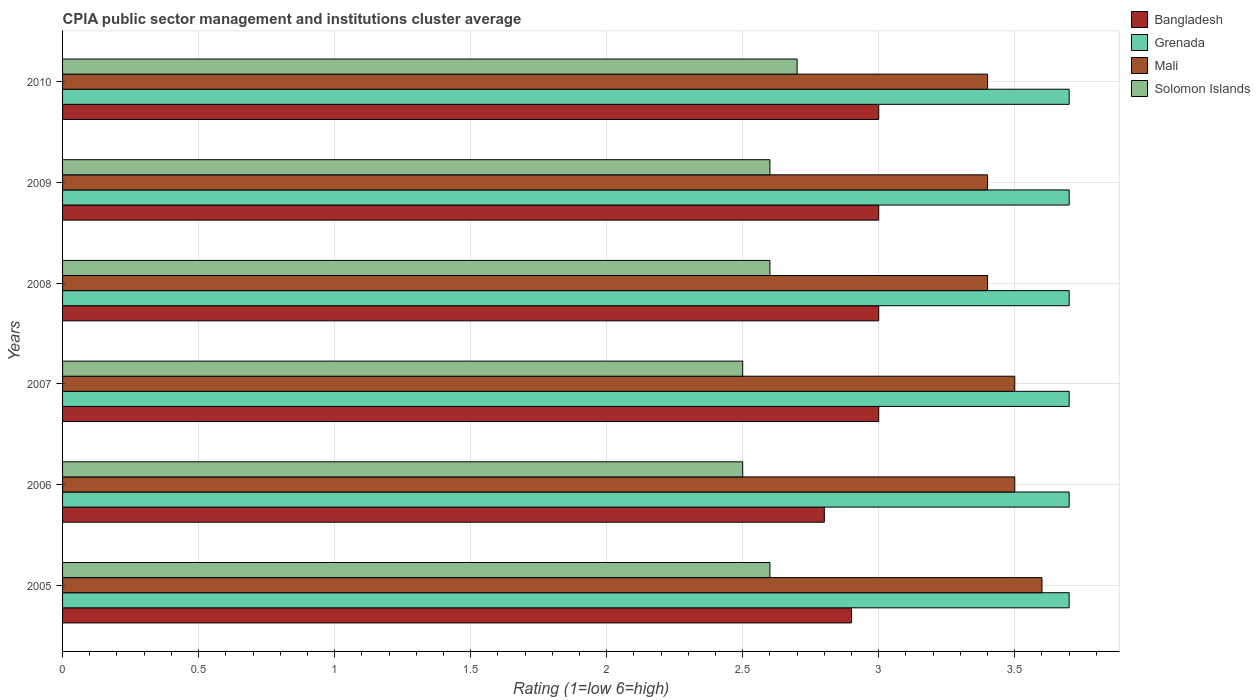How many groups of bars are there?
Your answer should be very brief. 6. Are the number of bars per tick equal to the number of legend labels?
Ensure brevity in your answer.  Yes. Are the number of bars on each tick of the Y-axis equal?
Provide a short and direct response. Yes. How many bars are there on the 4th tick from the bottom?
Offer a very short reply. 4. What is the label of the 3rd group of bars from the top?
Your answer should be compact. 2008. Across all years, what is the minimum CPIA rating in Bangladesh?
Your answer should be very brief. 2.8. In which year was the CPIA rating in Solomon Islands maximum?
Your answer should be compact. 2010. What is the total CPIA rating in Solomon Islands in the graph?
Ensure brevity in your answer.  15.5. What is the difference between the CPIA rating in Mali in 2007 and that in 2008?
Make the answer very short. 0.1. What is the average CPIA rating in Solomon Islands per year?
Your response must be concise. 2.58. In the year 2005, what is the difference between the CPIA rating in Mali and CPIA rating in Bangladesh?
Give a very brief answer. 0.7. What is the ratio of the CPIA rating in Bangladesh in 2007 to that in 2010?
Your answer should be compact. 1. What is the difference between the highest and the lowest CPIA rating in Solomon Islands?
Your response must be concise. 0.2. In how many years, is the CPIA rating in Mali greater than the average CPIA rating in Mali taken over all years?
Your response must be concise. 3. Is the sum of the CPIA rating in Grenada in 2008 and 2010 greater than the maximum CPIA rating in Solomon Islands across all years?
Offer a terse response. Yes. Is it the case that in every year, the sum of the CPIA rating in Grenada and CPIA rating in Bangladesh is greater than the sum of CPIA rating in Mali and CPIA rating in Solomon Islands?
Make the answer very short. Yes. What does the 3rd bar from the top in 2006 represents?
Your response must be concise. Grenada. What does the 2nd bar from the bottom in 2007 represents?
Make the answer very short. Grenada. How many bars are there?
Give a very brief answer. 24. Are all the bars in the graph horizontal?
Provide a short and direct response. Yes. What is the difference between two consecutive major ticks on the X-axis?
Offer a terse response. 0.5. Where does the legend appear in the graph?
Your answer should be compact. Top right. What is the title of the graph?
Give a very brief answer. CPIA public sector management and institutions cluster average. Does "United States" appear as one of the legend labels in the graph?
Provide a short and direct response. No. What is the label or title of the X-axis?
Make the answer very short. Rating (1=low 6=high). What is the label or title of the Y-axis?
Ensure brevity in your answer.  Years. What is the Rating (1=low 6=high) in Bangladesh in 2005?
Give a very brief answer. 2.9. What is the Rating (1=low 6=high) in Bangladesh in 2006?
Your answer should be very brief. 2.8. What is the Rating (1=low 6=high) in Grenada in 2006?
Offer a very short reply. 3.7. What is the Rating (1=low 6=high) of Grenada in 2007?
Your answer should be compact. 3.7. What is the Rating (1=low 6=high) in Bangladesh in 2008?
Keep it short and to the point. 3. What is the Rating (1=low 6=high) in Grenada in 2008?
Make the answer very short. 3.7. What is the Rating (1=low 6=high) of Mali in 2008?
Keep it short and to the point. 3.4. What is the Rating (1=low 6=high) of Solomon Islands in 2010?
Keep it short and to the point. 2.7. Across all years, what is the maximum Rating (1=low 6=high) in Bangladesh?
Your answer should be very brief. 3. Across all years, what is the maximum Rating (1=low 6=high) in Grenada?
Provide a succinct answer. 3.7. Across all years, what is the maximum Rating (1=low 6=high) of Mali?
Keep it short and to the point. 3.6. Across all years, what is the minimum Rating (1=low 6=high) in Bangladesh?
Ensure brevity in your answer.  2.8. Across all years, what is the minimum Rating (1=low 6=high) in Solomon Islands?
Keep it short and to the point. 2.5. What is the total Rating (1=low 6=high) in Mali in the graph?
Ensure brevity in your answer.  20.8. What is the total Rating (1=low 6=high) in Solomon Islands in the graph?
Provide a succinct answer. 15.5. What is the difference between the Rating (1=low 6=high) of Bangladesh in 2005 and that in 2006?
Your response must be concise. 0.1. What is the difference between the Rating (1=low 6=high) in Mali in 2005 and that in 2006?
Make the answer very short. 0.1. What is the difference between the Rating (1=low 6=high) of Grenada in 2005 and that in 2007?
Give a very brief answer. 0. What is the difference between the Rating (1=low 6=high) of Solomon Islands in 2005 and that in 2007?
Provide a short and direct response. 0.1. What is the difference between the Rating (1=low 6=high) in Grenada in 2005 and that in 2008?
Ensure brevity in your answer.  0. What is the difference between the Rating (1=low 6=high) of Solomon Islands in 2005 and that in 2008?
Offer a very short reply. 0. What is the difference between the Rating (1=low 6=high) of Mali in 2005 and that in 2009?
Your answer should be very brief. 0.2. What is the difference between the Rating (1=low 6=high) in Solomon Islands in 2005 and that in 2009?
Provide a succinct answer. 0. What is the difference between the Rating (1=low 6=high) in Bangladesh in 2005 and that in 2010?
Your answer should be very brief. -0.1. What is the difference between the Rating (1=low 6=high) in Solomon Islands in 2005 and that in 2010?
Provide a short and direct response. -0.1. What is the difference between the Rating (1=low 6=high) in Solomon Islands in 2006 and that in 2007?
Give a very brief answer. 0. What is the difference between the Rating (1=low 6=high) of Bangladesh in 2006 and that in 2008?
Your response must be concise. -0.2. What is the difference between the Rating (1=low 6=high) in Grenada in 2006 and that in 2008?
Keep it short and to the point. 0. What is the difference between the Rating (1=low 6=high) of Mali in 2006 and that in 2008?
Ensure brevity in your answer.  0.1. What is the difference between the Rating (1=low 6=high) in Grenada in 2006 and that in 2009?
Provide a short and direct response. 0. What is the difference between the Rating (1=low 6=high) in Solomon Islands in 2006 and that in 2009?
Your answer should be compact. -0.1. What is the difference between the Rating (1=low 6=high) of Solomon Islands in 2006 and that in 2010?
Offer a terse response. -0.2. What is the difference between the Rating (1=low 6=high) of Grenada in 2007 and that in 2008?
Give a very brief answer. 0. What is the difference between the Rating (1=low 6=high) of Solomon Islands in 2007 and that in 2008?
Offer a terse response. -0.1. What is the difference between the Rating (1=low 6=high) in Bangladesh in 2007 and that in 2009?
Offer a terse response. 0. What is the difference between the Rating (1=low 6=high) of Grenada in 2007 and that in 2009?
Keep it short and to the point. 0. What is the difference between the Rating (1=low 6=high) of Mali in 2007 and that in 2009?
Your answer should be very brief. 0.1. What is the difference between the Rating (1=low 6=high) of Bangladesh in 2007 and that in 2010?
Your answer should be compact. 0. What is the difference between the Rating (1=low 6=high) of Grenada in 2007 and that in 2010?
Offer a very short reply. 0. What is the difference between the Rating (1=low 6=high) of Bangladesh in 2008 and that in 2009?
Give a very brief answer. 0. What is the difference between the Rating (1=low 6=high) in Solomon Islands in 2008 and that in 2009?
Make the answer very short. 0. What is the difference between the Rating (1=low 6=high) of Solomon Islands in 2008 and that in 2010?
Offer a terse response. -0.1. What is the difference between the Rating (1=low 6=high) of Bangladesh in 2009 and that in 2010?
Your response must be concise. 0. What is the difference between the Rating (1=low 6=high) of Mali in 2009 and that in 2010?
Provide a succinct answer. 0. What is the difference between the Rating (1=low 6=high) of Bangladesh in 2005 and the Rating (1=low 6=high) of Mali in 2006?
Your response must be concise. -0.6. What is the difference between the Rating (1=low 6=high) of Bangladesh in 2005 and the Rating (1=low 6=high) of Solomon Islands in 2006?
Offer a very short reply. 0.4. What is the difference between the Rating (1=low 6=high) of Grenada in 2005 and the Rating (1=low 6=high) of Mali in 2006?
Offer a terse response. 0.2. What is the difference between the Rating (1=low 6=high) of Bangladesh in 2005 and the Rating (1=low 6=high) of Mali in 2007?
Offer a terse response. -0.6. What is the difference between the Rating (1=low 6=high) in Grenada in 2005 and the Rating (1=low 6=high) in Mali in 2007?
Offer a very short reply. 0.2. What is the difference between the Rating (1=low 6=high) in Grenada in 2005 and the Rating (1=low 6=high) in Solomon Islands in 2007?
Keep it short and to the point. 1.2. What is the difference between the Rating (1=low 6=high) in Mali in 2005 and the Rating (1=low 6=high) in Solomon Islands in 2007?
Your answer should be very brief. 1.1. What is the difference between the Rating (1=low 6=high) of Bangladesh in 2005 and the Rating (1=low 6=high) of Mali in 2008?
Your response must be concise. -0.5. What is the difference between the Rating (1=low 6=high) in Grenada in 2005 and the Rating (1=low 6=high) in Mali in 2008?
Give a very brief answer. 0.3. What is the difference between the Rating (1=low 6=high) in Mali in 2005 and the Rating (1=low 6=high) in Solomon Islands in 2008?
Keep it short and to the point. 1. What is the difference between the Rating (1=low 6=high) in Bangladesh in 2005 and the Rating (1=low 6=high) in Grenada in 2009?
Ensure brevity in your answer.  -0.8. What is the difference between the Rating (1=low 6=high) of Bangladesh in 2005 and the Rating (1=low 6=high) of Mali in 2009?
Offer a terse response. -0.5. What is the difference between the Rating (1=low 6=high) of Grenada in 2005 and the Rating (1=low 6=high) of Mali in 2009?
Provide a succinct answer. 0.3. What is the difference between the Rating (1=low 6=high) in Grenada in 2005 and the Rating (1=low 6=high) in Solomon Islands in 2009?
Keep it short and to the point. 1.1. What is the difference between the Rating (1=low 6=high) in Bangladesh in 2005 and the Rating (1=low 6=high) in Mali in 2010?
Provide a succinct answer. -0.5. What is the difference between the Rating (1=low 6=high) of Grenada in 2005 and the Rating (1=low 6=high) of Mali in 2010?
Your answer should be very brief. 0.3. What is the difference between the Rating (1=low 6=high) of Mali in 2005 and the Rating (1=low 6=high) of Solomon Islands in 2010?
Keep it short and to the point. 0.9. What is the difference between the Rating (1=low 6=high) of Bangladesh in 2006 and the Rating (1=low 6=high) of Mali in 2007?
Your answer should be compact. -0.7. What is the difference between the Rating (1=low 6=high) of Bangladesh in 2006 and the Rating (1=low 6=high) of Solomon Islands in 2007?
Make the answer very short. 0.3. What is the difference between the Rating (1=low 6=high) in Grenada in 2006 and the Rating (1=low 6=high) in Mali in 2007?
Your response must be concise. 0.2. What is the difference between the Rating (1=low 6=high) of Mali in 2006 and the Rating (1=low 6=high) of Solomon Islands in 2007?
Offer a very short reply. 1. What is the difference between the Rating (1=low 6=high) in Grenada in 2006 and the Rating (1=low 6=high) in Solomon Islands in 2008?
Offer a terse response. 1.1. What is the difference between the Rating (1=low 6=high) in Mali in 2006 and the Rating (1=low 6=high) in Solomon Islands in 2008?
Offer a very short reply. 0.9. What is the difference between the Rating (1=low 6=high) of Grenada in 2006 and the Rating (1=low 6=high) of Solomon Islands in 2009?
Offer a terse response. 1.1. What is the difference between the Rating (1=low 6=high) in Mali in 2006 and the Rating (1=low 6=high) in Solomon Islands in 2009?
Your answer should be very brief. 0.9. What is the difference between the Rating (1=low 6=high) of Bangladesh in 2006 and the Rating (1=low 6=high) of Grenada in 2010?
Ensure brevity in your answer.  -0.9. What is the difference between the Rating (1=low 6=high) in Bangladesh in 2006 and the Rating (1=low 6=high) in Solomon Islands in 2010?
Offer a very short reply. 0.1. What is the difference between the Rating (1=low 6=high) of Grenada in 2006 and the Rating (1=low 6=high) of Mali in 2010?
Ensure brevity in your answer.  0.3. What is the difference between the Rating (1=low 6=high) in Mali in 2006 and the Rating (1=low 6=high) in Solomon Islands in 2010?
Make the answer very short. 0.8. What is the difference between the Rating (1=low 6=high) of Bangladesh in 2007 and the Rating (1=low 6=high) of Mali in 2008?
Provide a short and direct response. -0.4. What is the difference between the Rating (1=low 6=high) in Grenada in 2007 and the Rating (1=low 6=high) in Solomon Islands in 2008?
Ensure brevity in your answer.  1.1. What is the difference between the Rating (1=low 6=high) of Mali in 2007 and the Rating (1=low 6=high) of Solomon Islands in 2008?
Your answer should be compact. 0.9. What is the difference between the Rating (1=low 6=high) of Bangladesh in 2007 and the Rating (1=low 6=high) of Grenada in 2009?
Make the answer very short. -0.7. What is the difference between the Rating (1=low 6=high) in Bangladesh in 2007 and the Rating (1=low 6=high) in Mali in 2009?
Offer a very short reply. -0.4. What is the difference between the Rating (1=low 6=high) of Bangladesh in 2007 and the Rating (1=low 6=high) of Grenada in 2010?
Your response must be concise. -0.7. What is the difference between the Rating (1=low 6=high) in Bangladesh in 2007 and the Rating (1=low 6=high) in Mali in 2010?
Your answer should be compact. -0.4. What is the difference between the Rating (1=low 6=high) in Bangladesh in 2007 and the Rating (1=low 6=high) in Solomon Islands in 2010?
Ensure brevity in your answer.  0.3. What is the difference between the Rating (1=low 6=high) of Grenada in 2007 and the Rating (1=low 6=high) of Mali in 2010?
Provide a succinct answer. 0.3. What is the difference between the Rating (1=low 6=high) in Grenada in 2007 and the Rating (1=low 6=high) in Solomon Islands in 2010?
Provide a short and direct response. 1. What is the difference between the Rating (1=low 6=high) in Bangladesh in 2008 and the Rating (1=low 6=high) in Mali in 2009?
Give a very brief answer. -0.4. What is the difference between the Rating (1=low 6=high) in Bangladesh in 2008 and the Rating (1=low 6=high) in Solomon Islands in 2009?
Make the answer very short. 0.4. What is the difference between the Rating (1=low 6=high) of Bangladesh in 2008 and the Rating (1=low 6=high) of Grenada in 2010?
Provide a short and direct response. -0.7. What is the difference between the Rating (1=low 6=high) of Bangladesh in 2008 and the Rating (1=low 6=high) of Solomon Islands in 2010?
Provide a succinct answer. 0.3. What is the difference between the Rating (1=low 6=high) of Grenada in 2008 and the Rating (1=low 6=high) of Mali in 2010?
Provide a short and direct response. 0.3. What is the difference between the Rating (1=low 6=high) in Bangladesh in 2009 and the Rating (1=low 6=high) in Grenada in 2010?
Give a very brief answer. -0.7. What is the difference between the Rating (1=low 6=high) of Bangladesh in 2009 and the Rating (1=low 6=high) of Solomon Islands in 2010?
Offer a terse response. 0.3. What is the average Rating (1=low 6=high) in Bangladesh per year?
Your answer should be compact. 2.95. What is the average Rating (1=low 6=high) in Grenada per year?
Provide a short and direct response. 3.7. What is the average Rating (1=low 6=high) of Mali per year?
Give a very brief answer. 3.47. What is the average Rating (1=low 6=high) in Solomon Islands per year?
Ensure brevity in your answer.  2.58. In the year 2005, what is the difference between the Rating (1=low 6=high) of Bangladesh and Rating (1=low 6=high) of Grenada?
Give a very brief answer. -0.8. In the year 2005, what is the difference between the Rating (1=low 6=high) in Bangladesh and Rating (1=low 6=high) in Solomon Islands?
Your response must be concise. 0.3. In the year 2005, what is the difference between the Rating (1=low 6=high) of Grenada and Rating (1=low 6=high) of Mali?
Make the answer very short. 0.1. In the year 2005, what is the difference between the Rating (1=low 6=high) in Mali and Rating (1=low 6=high) in Solomon Islands?
Provide a succinct answer. 1. In the year 2006, what is the difference between the Rating (1=low 6=high) of Bangladesh and Rating (1=low 6=high) of Solomon Islands?
Provide a short and direct response. 0.3. In the year 2008, what is the difference between the Rating (1=low 6=high) in Bangladesh and Rating (1=low 6=high) in Grenada?
Offer a terse response. -0.7. In the year 2008, what is the difference between the Rating (1=low 6=high) in Bangladesh and Rating (1=low 6=high) in Mali?
Give a very brief answer. -0.4. In the year 2008, what is the difference between the Rating (1=low 6=high) of Grenada and Rating (1=low 6=high) of Mali?
Your answer should be compact. 0.3. In the year 2008, what is the difference between the Rating (1=low 6=high) of Grenada and Rating (1=low 6=high) of Solomon Islands?
Make the answer very short. 1.1. In the year 2008, what is the difference between the Rating (1=low 6=high) of Mali and Rating (1=low 6=high) of Solomon Islands?
Keep it short and to the point. 0.8. In the year 2009, what is the difference between the Rating (1=low 6=high) in Bangladesh and Rating (1=low 6=high) in Grenada?
Provide a short and direct response. -0.7. In the year 2009, what is the difference between the Rating (1=low 6=high) in Bangladesh and Rating (1=low 6=high) in Mali?
Provide a succinct answer. -0.4. In the year 2009, what is the difference between the Rating (1=low 6=high) in Bangladesh and Rating (1=low 6=high) in Solomon Islands?
Your answer should be very brief. 0.4. In the year 2009, what is the difference between the Rating (1=low 6=high) of Grenada and Rating (1=low 6=high) of Mali?
Ensure brevity in your answer.  0.3. In the year 2009, what is the difference between the Rating (1=low 6=high) of Grenada and Rating (1=low 6=high) of Solomon Islands?
Make the answer very short. 1.1. In the year 2009, what is the difference between the Rating (1=low 6=high) of Mali and Rating (1=low 6=high) of Solomon Islands?
Give a very brief answer. 0.8. In the year 2010, what is the difference between the Rating (1=low 6=high) of Bangladesh and Rating (1=low 6=high) of Mali?
Offer a very short reply. -0.4. In the year 2010, what is the difference between the Rating (1=low 6=high) of Bangladesh and Rating (1=low 6=high) of Solomon Islands?
Your answer should be very brief. 0.3. In the year 2010, what is the difference between the Rating (1=low 6=high) in Mali and Rating (1=low 6=high) in Solomon Islands?
Ensure brevity in your answer.  0.7. What is the ratio of the Rating (1=low 6=high) in Bangladesh in 2005 to that in 2006?
Your response must be concise. 1.04. What is the ratio of the Rating (1=low 6=high) in Grenada in 2005 to that in 2006?
Provide a short and direct response. 1. What is the ratio of the Rating (1=low 6=high) of Mali in 2005 to that in 2006?
Provide a short and direct response. 1.03. What is the ratio of the Rating (1=low 6=high) of Solomon Islands in 2005 to that in 2006?
Keep it short and to the point. 1.04. What is the ratio of the Rating (1=low 6=high) of Bangladesh in 2005 to that in 2007?
Ensure brevity in your answer.  0.97. What is the ratio of the Rating (1=low 6=high) of Grenada in 2005 to that in 2007?
Make the answer very short. 1. What is the ratio of the Rating (1=low 6=high) of Mali in 2005 to that in 2007?
Provide a succinct answer. 1.03. What is the ratio of the Rating (1=low 6=high) of Solomon Islands in 2005 to that in 2007?
Your answer should be compact. 1.04. What is the ratio of the Rating (1=low 6=high) in Bangladesh in 2005 to that in 2008?
Your answer should be compact. 0.97. What is the ratio of the Rating (1=low 6=high) in Mali in 2005 to that in 2008?
Your answer should be very brief. 1.06. What is the ratio of the Rating (1=low 6=high) of Bangladesh in 2005 to that in 2009?
Provide a succinct answer. 0.97. What is the ratio of the Rating (1=low 6=high) of Grenada in 2005 to that in 2009?
Your answer should be very brief. 1. What is the ratio of the Rating (1=low 6=high) in Mali in 2005 to that in 2009?
Make the answer very short. 1.06. What is the ratio of the Rating (1=low 6=high) in Solomon Islands in 2005 to that in 2009?
Provide a short and direct response. 1. What is the ratio of the Rating (1=low 6=high) of Bangladesh in 2005 to that in 2010?
Your response must be concise. 0.97. What is the ratio of the Rating (1=low 6=high) of Grenada in 2005 to that in 2010?
Your response must be concise. 1. What is the ratio of the Rating (1=low 6=high) in Mali in 2005 to that in 2010?
Offer a terse response. 1.06. What is the ratio of the Rating (1=low 6=high) in Solomon Islands in 2005 to that in 2010?
Offer a very short reply. 0.96. What is the ratio of the Rating (1=low 6=high) of Bangladesh in 2006 to that in 2007?
Give a very brief answer. 0.93. What is the ratio of the Rating (1=low 6=high) in Mali in 2006 to that in 2008?
Your answer should be very brief. 1.03. What is the ratio of the Rating (1=low 6=high) in Solomon Islands in 2006 to that in 2008?
Offer a terse response. 0.96. What is the ratio of the Rating (1=low 6=high) of Bangladesh in 2006 to that in 2009?
Your answer should be very brief. 0.93. What is the ratio of the Rating (1=low 6=high) of Mali in 2006 to that in 2009?
Offer a very short reply. 1.03. What is the ratio of the Rating (1=low 6=high) of Solomon Islands in 2006 to that in 2009?
Keep it short and to the point. 0.96. What is the ratio of the Rating (1=low 6=high) in Bangladesh in 2006 to that in 2010?
Provide a short and direct response. 0.93. What is the ratio of the Rating (1=low 6=high) of Mali in 2006 to that in 2010?
Make the answer very short. 1.03. What is the ratio of the Rating (1=low 6=high) of Solomon Islands in 2006 to that in 2010?
Provide a short and direct response. 0.93. What is the ratio of the Rating (1=low 6=high) in Bangladesh in 2007 to that in 2008?
Ensure brevity in your answer.  1. What is the ratio of the Rating (1=low 6=high) in Grenada in 2007 to that in 2008?
Offer a very short reply. 1. What is the ratio of the Rating (1=low 6=high) in Mali in 2007 to that in 2008?
Your response must be concise. 1.03. What is the ratio of the Rating (1=low 6=high) in Solomon Islands in 2007 to that in 2008?
Your answer should be very brief. 0.96. What is the ratio of the Rating (1=low 6=high) of Mali in 2007 to that in 2009?
Give a very brief answer. 1.03. What is the ratio of the Rating (1=low 6=high) of Solomon Islands in 2007 to that in 2009?
Offer a terse response. 0.96. What is the ratio of the Rating (1=low 6=high) in Bangladesh in 2007 to that in 2010?
Your response must be concise. 1. What is the ratio of the Rating (1=low 6=high) of Grenada in 2007 to that in 2010?
Provide a short and direct response. 1. What is the ratio of the Rating (1=low 6=high) of Mali in 2007 to that in 2010?
Your answer should be compact. 1.03. What is the ratio of the Rating (1=low 6=high) in Solomon Islands in 2007 to that in 2010?
Offer a terse response. 0.93. What is the ratio of the Rating (1=low 6=high) of Bangladesh in 2008 to that in 2009?
Your answer should be very brief. 1. What is the ratio of the Rating (1=low 6=high) in Grenada in 2008 to that in 2009?
Offer a terse response. 1. What is the ratio of the Rating (1=low 6=high) of Bangladesh in 2009 to that in 2010?
Provide a succinct answer. 1. What is the ratio of the Rating (1=low 6=high) in Mali in 2009 to that in 2010?
Make the answer very short. 1. What is the ratio of the Rating (1=low 6=high) in Solomon Islands in 2009 to that in 2010?
Give a very brief answer. 0.96. What is the difference between the highest and the second highest Rating (1=low 6=high) in Grenada?
Offer a very short reply. 0. What is the difference between the highest and the second highest Rating (1=low 6=high) of Mali?
Offer a terse response. 0.1. What is the difference between the highest and the second highest Rating (1=low 6=high) in Solomon Islands?
Keep it short and to the point. 0.1. What is the difference between the highest and the lowest Rating (1=low 6=high) in Solomon Islands?
Offer a very short reply. 0.2. 